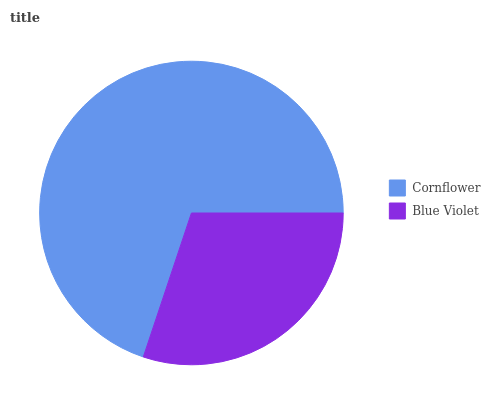Is Blue Violet the minimum?
Answer yes or no. Yes. Is Cornflower the maximum?
Answer yes or no. Yes. Is Blue Violet the maximum?
Answer yes or no. No. Is Cornflower greater than Blue Violet?
Answer yes or no. Yes. Is Blue Violet less than Cornflower?
Answer yes or no. Yes. Is Blue Violet greater than Cornflower?
Answer yes or no. No. Is Cornflower less than Blue Violet?
Answer yes or no. No. Is Cornflower the high median?
Answer yes or no. Yes. Is Blue Violet the low median?
Answer yes or no. Yes. Is Blue Violet the high median?
Answer yes or no. No. Is Cornflower the low median?
Answer yes or no. No. 